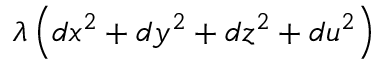Convert formula to latex. <formula><loc_0><loc_0><loc_500><loc_500>\lambda \left ( d x ^ { 2 } + d y ^ { 2 } + d z ^ { 2 } + d u ^ { 2 } \right )</formula> 